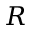<formula> <loc_0><loc_0><loc_500><loc_500>R</formula> 